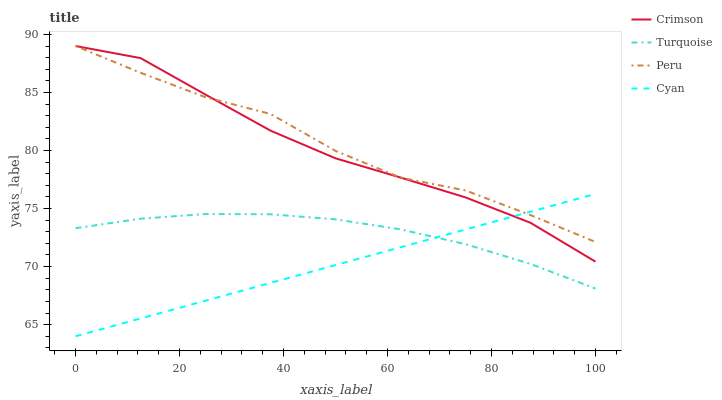Does Cyan have the minimum area under the curve?
Answer yes or no. Yes. Does Peru have the maximum area under the curve?
Answer yes or no. Yes. Does Turquoise have the minimum area under the curve?
Answer yes or no. No. Does Turquoise have the maximum area under the curve?
Answer yes or no. No. Is Cyan the smoothest?
Answer yes or no. Yes. Is Peru the roughest?
Answer yes or no. Yes. Is Turquoise the smoothest?
Answer yes or no. No. Is Turquoise the roughest?
Answer yes or no. No. Does Cyan have the lowest value?
Answer yes or no. Yes. Does Turquoise have the lowest value?
Answer yes or no. No. Does Peru have the highest value?
Answer yes or no. Yes. Does Cyan have the highest value?
Answer yes or no. No. Is Turquoise less than Crimson?
Answer yes or no. Yes. Is Crimson greater than Turquoise?
Answer yes or no. Yes. Does Peru intersect Cyan?
Answer yes or no. Yes. Is Peru less than Cyan?
Answer yes or no. No. Is Peru greater than Cyan?
Answer yes or no. No. Does Turquoise intersect Crimson?
Answer yes or no. No. 